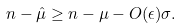<formula> <loc_0><loc_0><loc_500><loc_500>n - \hat { \mu } \geq n - \mu - O ( \epsilon ) \sigma .</formula> 